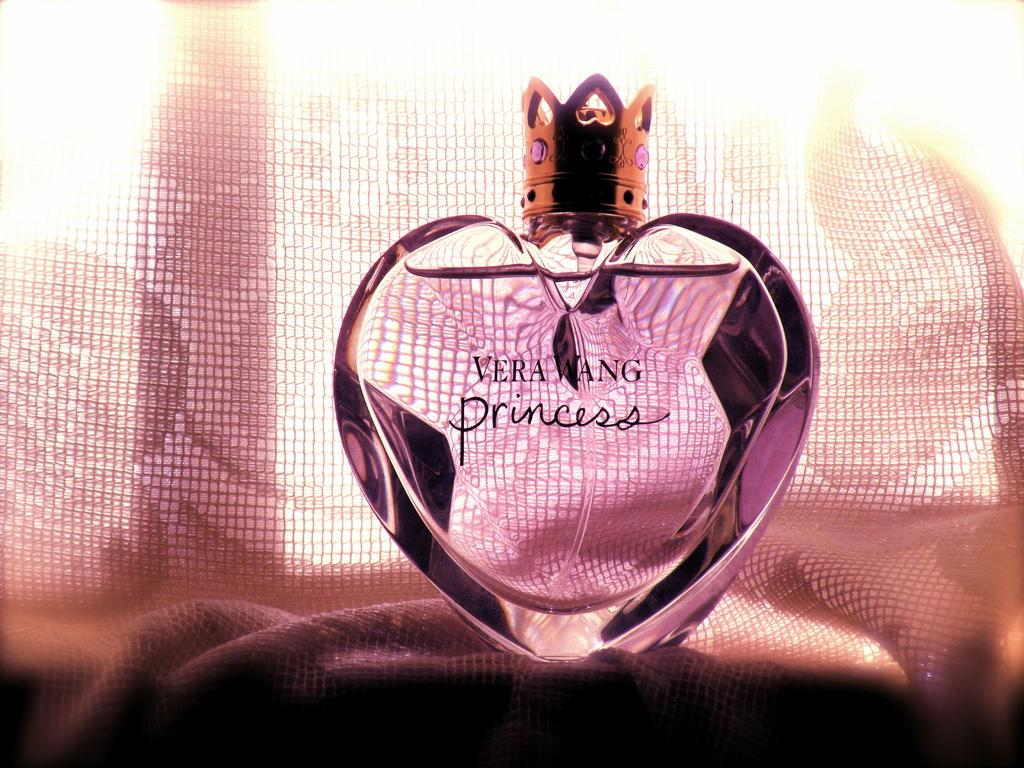Provide a one-sentence caption for the provided image. A pink heart shaped bottle of Vera Wang Princess perfume. 